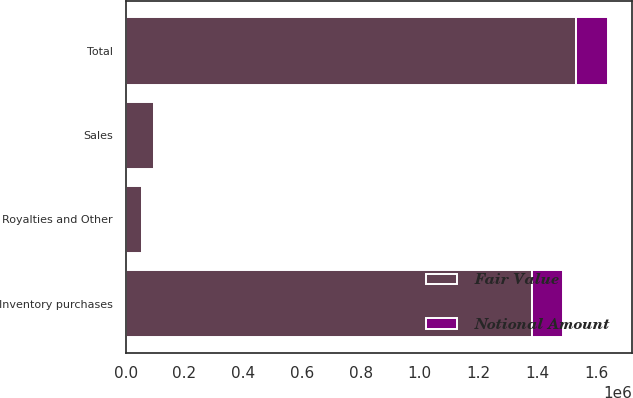Convert chart. <chart><loc_0><loc_0><loc_500><loc_500><stacked_bar_chart><ecel><fcel>Inventory purchases<fcel>Sales<fcel>Royalties and Other<fcel>Total<nl><fcel>Fair Value<fcel>1.38049e+06<fcel>97350<fcel>54360<fcel>1.5322e+06<nl><fcel>Notional Amount<fcel>108521<fcel>803<fcel>1886<fcel>107438<nl></chart> 